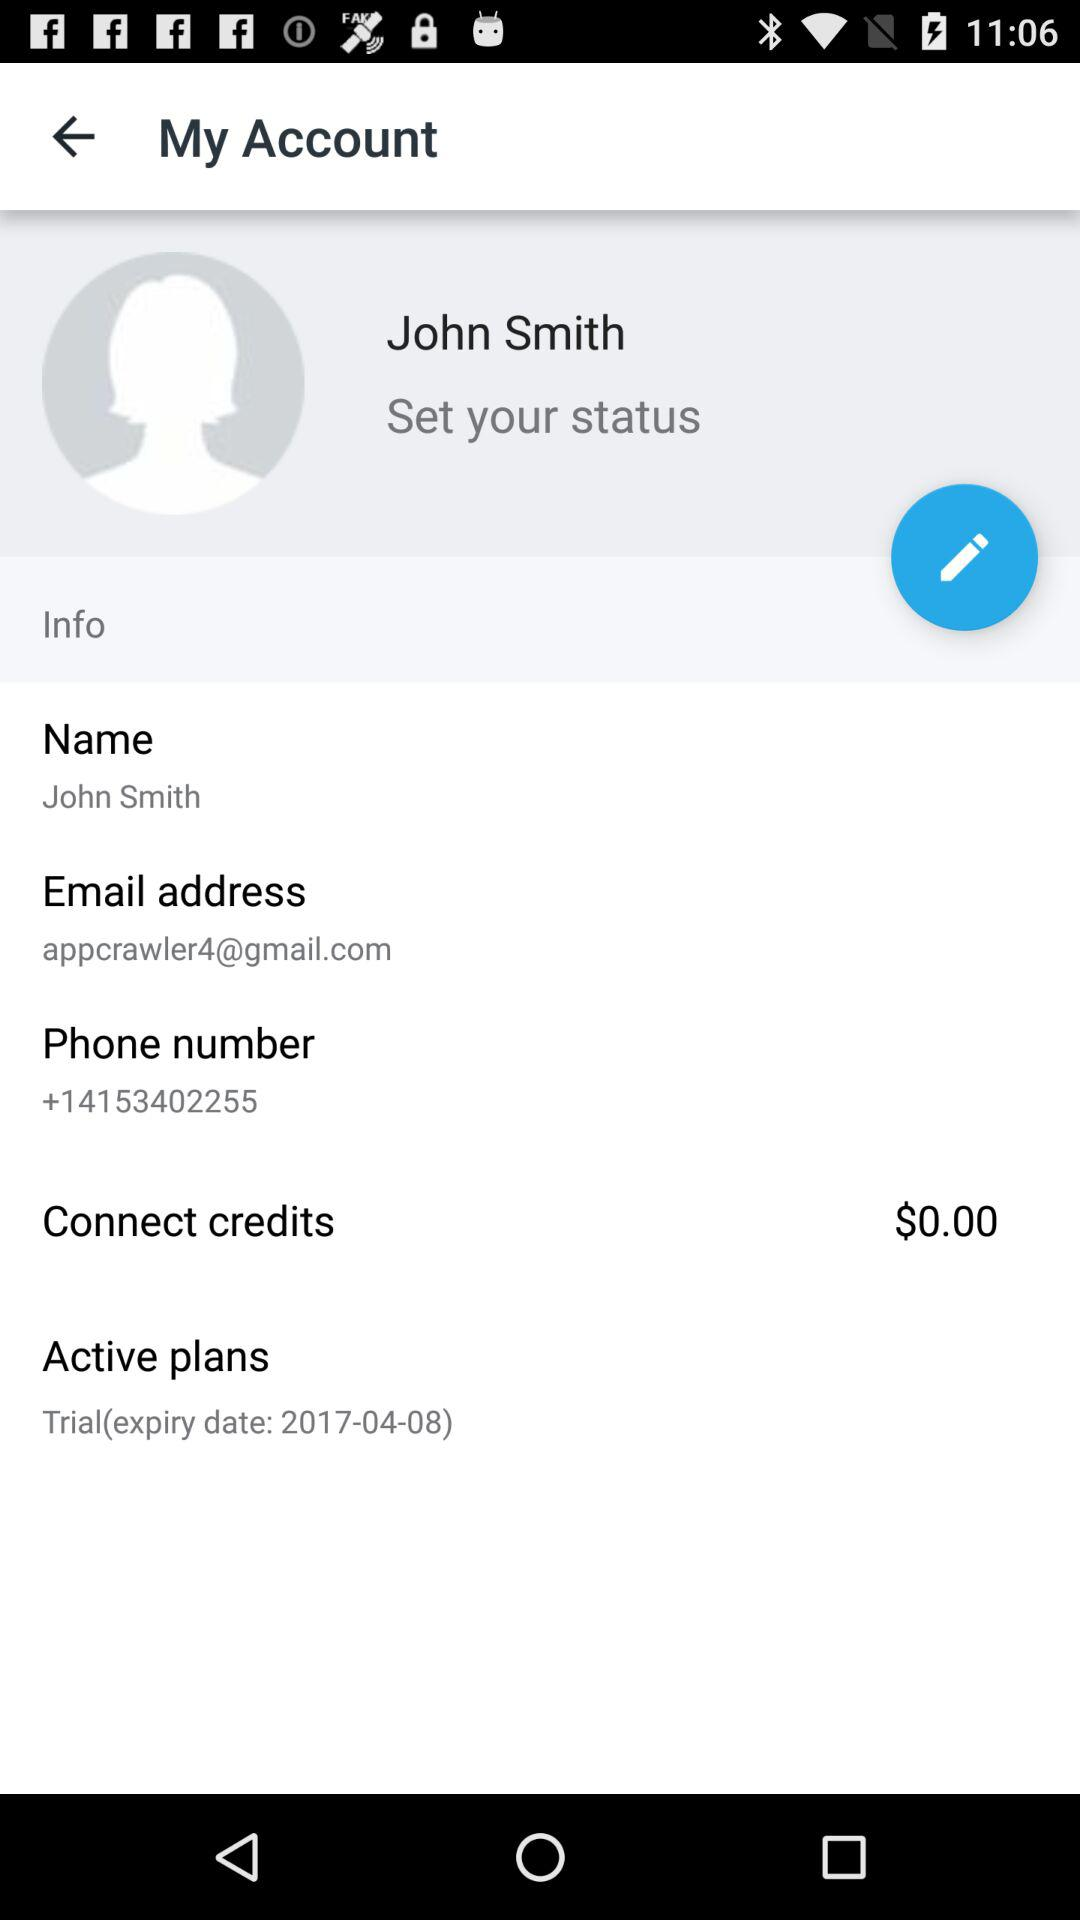What is the expiration date of the active plan? The expiration date is April 8, 2017. 